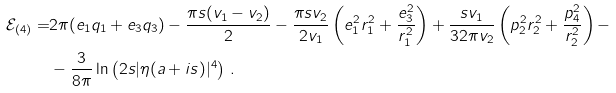Convert formula to latex. <formula><loc_0><loc_0><loc_500><loc_500>\mathcal { E } _ { ( 4 ) } = & 2 \pi ( e _ { 1 } q _ { 1 } + e _ { 3 } q _ { 3 } ) - \frac { \pi s ( v _ { 1 } - v _ { 2 } ) } { 2 } - \frac { \pi s v _ { 2 } } { 2 v _ { 1 } } \left ( e _ { 1 } ^ { 2 } r _ { 1 } ^ { 2 } + \frac { e _ { 3 } ^ { 2 } } { r _ { 1 } ^ { 2 } } \right ) + \frac { s v _ { 1 } } { 3 2 \pi v _ { 2 } } \left ( p _ { 2 } ^ { 2 } r _ { 2 } ^ { 2 } + \frac { p _ { 4 } ^ { 2 } } { r _ { 2 } ^ { 2 } } \right ) - \\ & - \frac { 3 } { 8 \pi } \ln \left ( 2 s | \eta ( a + i s ) | ^ { 4 } \right ) \, .</formula> 